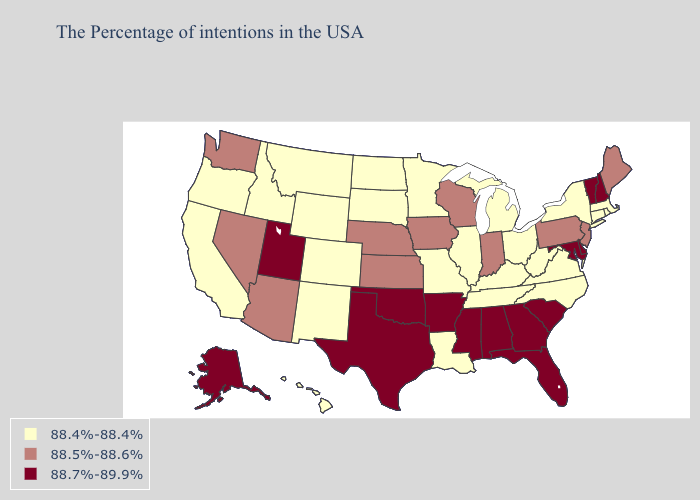Name the states that have a value in the range 88.7%-89.9%?
Answer briefly. New Hampshire, Vermont, Delaware, Maryland, South Carolina, Florida, Georgia, Alabama, Mississippi, Arkansas, Oklahoma, Texas, Utah, Alaska. What is the lowest value in states that border Rhode Island?
Give a very brief answer. 88.4%-88.4%. Does the first symbol in the legend represent the smallest category?
Write a very short answer. Yes. What is the value of Virginia?
Quick response, please. 88.4%-88.4%. Name the states that have a value in the range 88.7%-89.9%?
Be succinct. New Hampshire, Vermont, Delaware, Maryland, South Carolina, Florida, Georgia, Alabama, Mississippi, Arkansas, Oklahoma, Texas, Utah, Alaska. Name the states that have a value in the range 88.4%-88.4%?
Concise answer only. Massachusetts, Rhode Island, Connecticut, New York, Virginia, North Carolina, West Virginia, Ohio, Michigan, Kentucky, Tennessee, Illinois, Louisiana, Missouri, Minnesota, South Dakota, North Dakota, Wyoming, Colorado, New Mexico, Montana, Idaho, California, Oregon, Hawaii. What is the lowest value in the USA?
Write a very short answer. 88.4%-88.4%. Does Kentucky have the same value as Montana?
Short answer required. Yes. Does Idaho have the same value as Alaska?
Short answer required. No. Does Delaware have a lower value than Alaska?
Give a very brief answer. No. Name the states that have a value in the range 88.4%-88.4%?
Give a very brief answer. Massachusetts, Rhode Island, Connecticut, New York, Virginia, North Carolina, West Virginia, Ohio, Michigan, Kentucky, Tennessee, Illinois, Louisiana, Missouri, Minnesota, South Dakota, North Dakota, Wyoming, Colorado, New Mexico, Montana, Idaho, California, Oregon, Hawaii. Does Virginia have the same value as Vermont?
Answer briefly. No. Does Illinois have the same value as Colorado?
Keep it brief. Yes. 